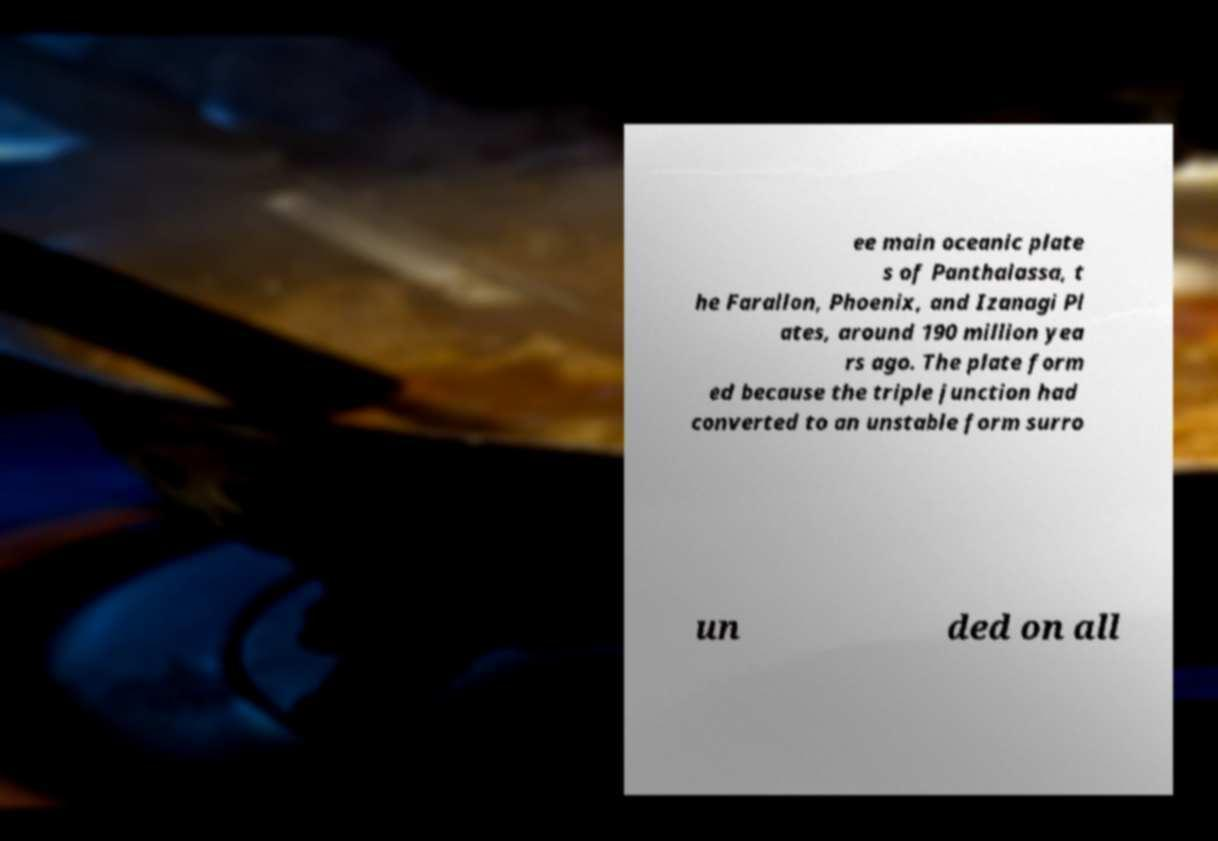There's text embedded in this image that I need extracted. Can you transcribe it verbatim? ee main oceanic plate s of Panthalassa, t he Farallon, Phoenix, and Izanagi Pl ates, around 190 million yea rs ago. The plate form ed because the triple junction had converted to an unstable form surro un ded on all 